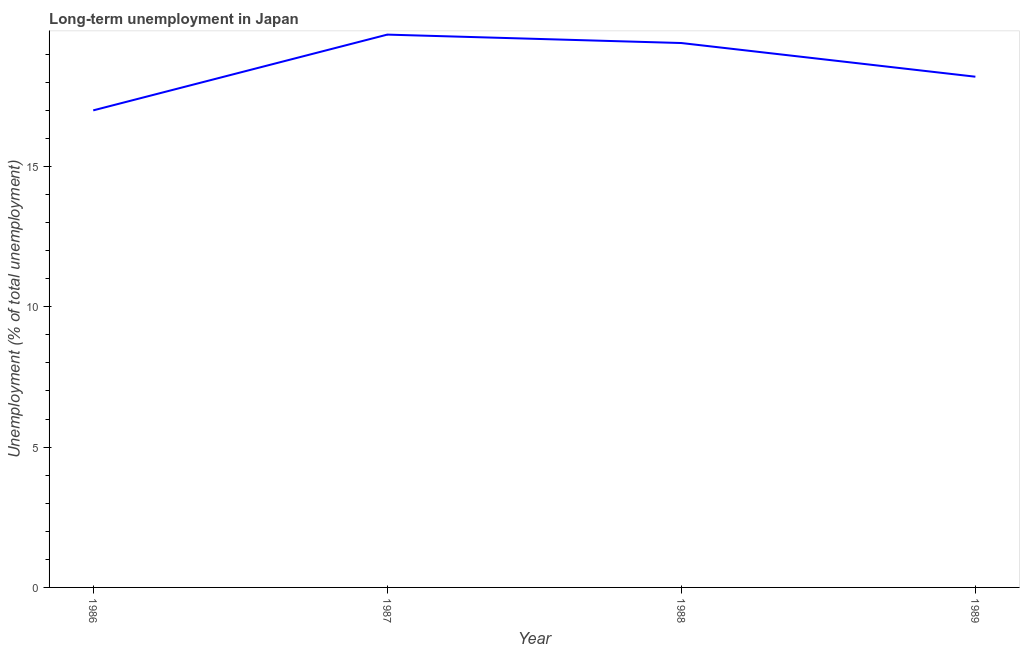What is the long-term unemployment in 1987?
Your answer should be very brief. 19.7. Across all years, what is the maximum long-term unemployment?
Your answer should be very brief. 19.7. Across all years, what is the minimum long-term unemployment?
Provide a succinct answer. 17. In which year was the long-term unemployment maximum?
Your answer should be very brief. 1987. In which year was the long-term unemployment minimum?
Provide a short and direct response. 1986. What is the sum of the long-term unemployment?
Keep it short and to the point. 74.3. What is the difference between the long-term unemployment in 1986 and 1987?
Keep it short and to the point. -2.7. What is the average long-term unemployment per year?
Provide a succinct answer. 18.58. What is the median long-term unemployment?
Give a very brief answer. 18.8. Do a majority of the years between 1986 and 1989 (inclusive) have long-term unemployment greater than 3 %?
Your answer should be compact. Yes. What is the ratio of the long-term unemployment in 1986 to that in 1988?
Offer a very short reply. 0.88. What is the difference between the highest and the second highest long-term unemployment?
Your answer should be very brief. 0.3. Is the sum of the long-term unemployment in 1986 and 1988 greater than the maximum long-term unemployment across all years?
Ensure brevity in your answer.  Yes. What is the difference between the highest and the lowest long-term unemployment?
Your response must be concise. 2.7. In how many years, is the long-term unemployment greater than the average long-term unemployment taken over all years?
Offer a terse response. 2. How many lines are there?
Give a very brief answer. 1. Does the graph contain any zero values?
Make the answer very short. No. What is the title of the graph?
Make the answer very short. Long-term unemployment in Japan. What is the label or title of the X-axis?
Keep it short and to the point. Year. What is the label or title of the Y-axis?
Offer a very short reply. Unemployment (% of total unemployment). What is the Unemployment (% of total unemployment) of 1986?
Give a very brief answer. 17. What is the Unemployment (% of total unemployment) of 1987?
Give a very brief answer. 19.7. What is the Unemployment (% of total unemployment) in 1988?
Ensure brevity in your answer.  19.4. What is the Unemployment (% of total unemployment) in 1989?
Your answer should be compact. 18.2. What is the difference between the Unemployment (% of total unemployment) in 1986 and 1987?
Make the answer very short. -2.7. What is the difference between the Unemployment (% of total unemployment) in 1987 and 1988?
Your answer should be compact. 0.3. What is the difference between the Unemployment (% of total unemployment) in 1988 and 1989?
Provide a succinct answer. 1.2. What is the ratio of the Unemployment (% of total unemployment) in 1986 to that in 1987?
Ensure brevity in your answer.  0.86. What is the ratio of the Unemployment (% of total unemployment) in 1986 to that in 1988?
Your response must be concise. 0.88. What is the ratio of the Unemployment (% of total unemployment) in 1986 to that in 1989?
Make the answer very short. 0.93. What is the ratio of the Unemployment (% of total unemployment) in 1987 to that in 1989?
Your answer should be compact. 1.08. What is the ratio of the Unemployment (% of total unemployment) in 1988 to that in 1989?
Provide a succinct answer. 1.07. 